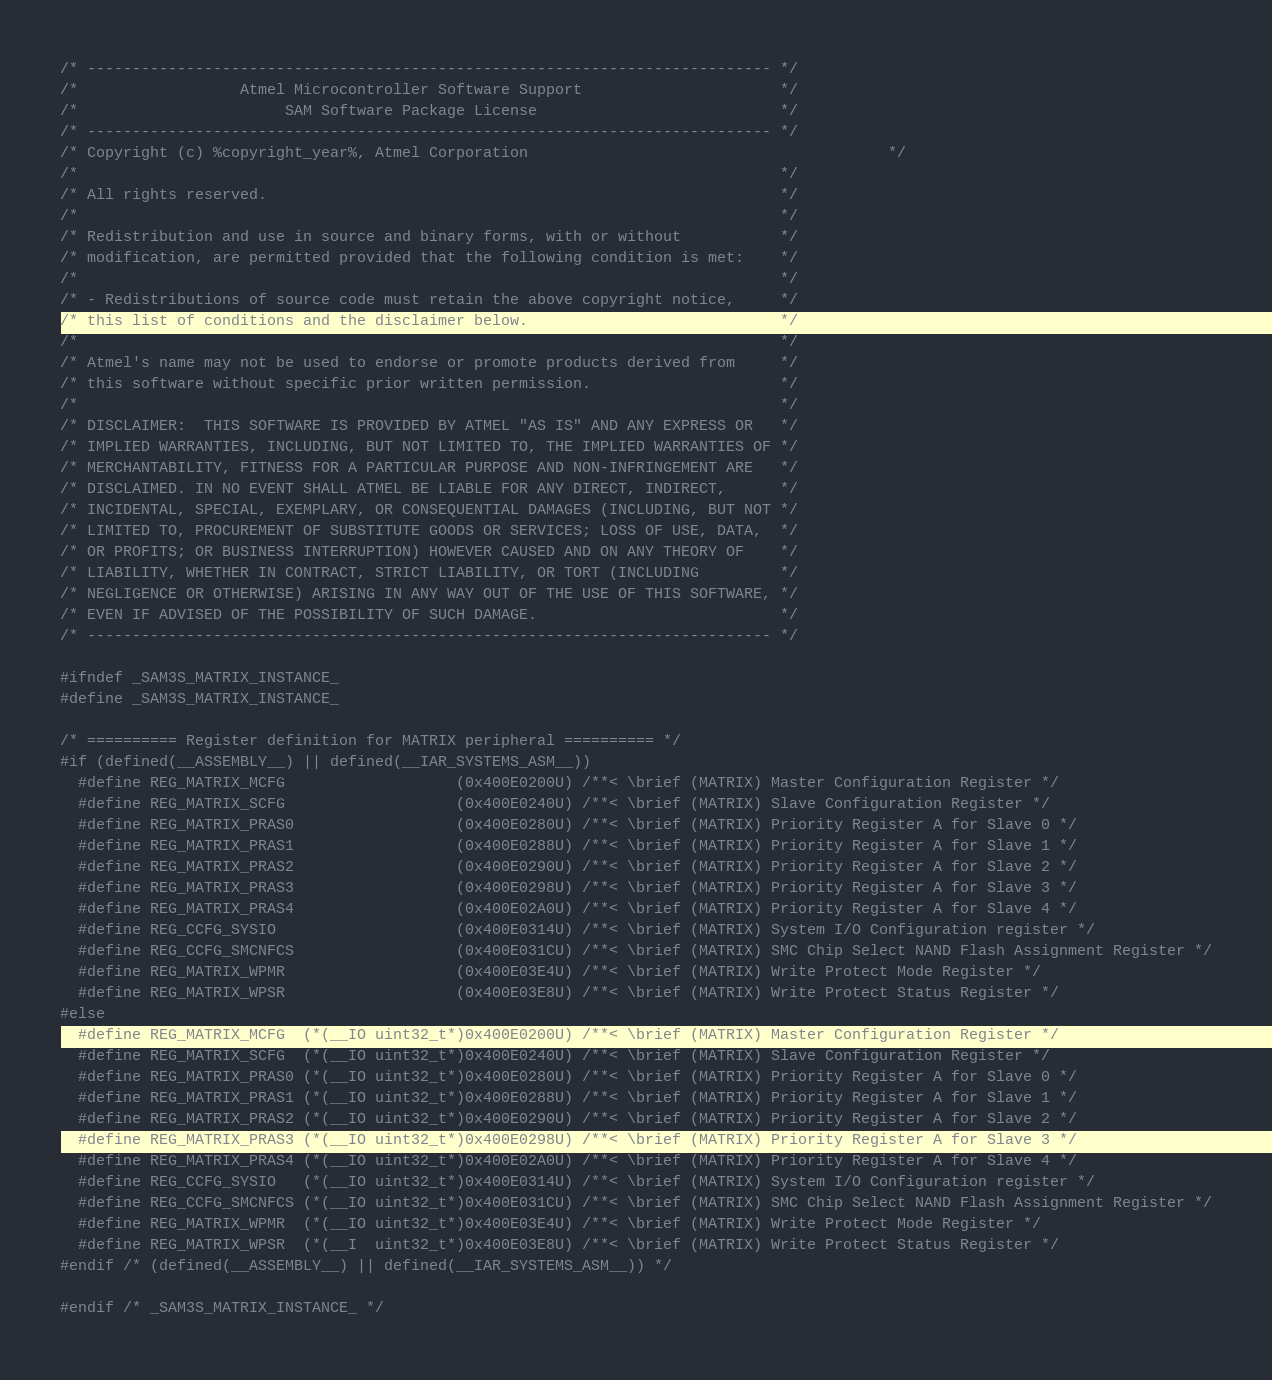<code> <loc_0><loc_0><loc_500><loc_500><_C_>/* ---------------------------------------------------------------------------- */
/*                  Atmel Microcontroller Software Support                      */
/*                       SAM Software Package License                           */
/* ---------------------------------------------------------------------------- */
/* Copyright (c) %copyright_year%, Atmel Corporation                                        */
/*                                                                              */
/* All rights reserved.                                                         */
/*                                                                              */
/* Redistribution and use in source and binary forms, with or without           */
/* modification, are permitted provided that the following condition is met:    */
/*                                                                              */
/* - Redistributions of source code must retain the above copyright notice,     */
/* this list of conditions and the disclaimer below.                            */
/*                                                                              */
/* Atmel's name may not be used to endorse or promote products derived from     */
/* this software without specific prior written permission.                     */
/*                                                                              */
/* DISCLAIMER:  THIS SOFTWARE IS PROVIDED BY ATMEL "AS IS" AND ANY EXPRESS OR   */
/* IMPLIED WARRANTIES, INCLUDING, BUT NOT LIMITED TO, THE IMPLIED WARRANTIES OF */
/* MERCHANTABILITY, FITNESS FOR A PARTICULAR PURPOSE AND NON-INFRINGEMENT ARE   */
/* DISCLAIMED. IN NO EVENT SHALL ATMEL BE LIABLE FOR ANY DIRECT, INDIRECT,      */
/* INCIDENTAL, SPECIAL, EXEMPLARY, OR CONSEQUENTIAL DAMAGES (INCLUDING, BUT NOT */
/* LIMITED TO, PROCUREMENT OF SUBSTITUTE GOODS OR SERVICES; LOSS OF USE, DATA,  */
/* OR PROFITS; OR BUSINESS INTERRUPTION) HOWEVER CAUSED AND ON ANY THEORY OF    */
/* LIABILITY, WHETHER IN CONTRACT, STRICT LIABILITY, OR TORT (INCLUDING         */
/* NEGLIGENCE OR OTHERWISE) ARISING IN ANY WAY OUT OF THE USE OF THIS SOFTWARE, */
/* EVEN IF ADVISED OF THE POSSIBILITY OF SUCH DAMAGE.                           */
/* ---------------------------------------------------------------------------- */

#ifndef _SAM3S_MATRIX_INSTANCE_
#define _SAM3S_MATRIX_INSTANCE_

/* ========== Register definition for MATRIX peripheral ========== */
#if (defined(__ASSEMBLY__) || defined(__IAR_SYSTEMS_ASM__))
  #define REG_MATRIX_MCFG                   (0x400E0200U) /**< \brief (MATRIX) Master Configuration Register */
  #define REG_MATRIX_SCFG                   (0x400E0240U) /**< \brief (MATRIX) Slave Configuration Register */
  #define REG_MATRIX_PRAS0                  (0x400E0280U) /**< \brief (MATRIX) Priority Register A for Slave 0 */
  #define REG_MATRIX_PRAS1                  (0x400E0288U) /**< \brief (MATRIX) Priority Register A for Slave 1 */
  #define REG_MATRIX_PRAS2                  (0x400E0290U) /**< \brief (MATRIX) Priority Register A for Slave 2 */
  #define REG_MATRIX_PRAS3                  (0x400E0298U) /**< \brief (MATRIX) Priority Register A for Slave 3 */
  #define REG_MATRIX_PRAS4                  (0x400E02A0U) /**< \brief (MATRIX) Priority Register A for Slave 4 */
  #define REG_CCFG_SYSIO                    (0x400E0314U) /**< \brief (MATRIX) System I/O Configuration register */
  #define REG_CCFG_SMCNFCS                  (0x400E031CU) /**< \brief (MATRIX) SMC Chip Select NAND Flash Assignment Register */
  #define REG_MATRIX_WPMR                   (0x400E03E4U) /**< \brief (MATRIX) Write Protect Mode Register */
  #define REG_MATRIX_WPSR                   (0x400E03E8U) /**< \brief (MATRIX) Write Protect Status Register */
#else
  #define REG_MATRIX_MCFG  (*(__IO uint32_t*)0x400E0200U) /**< \brief (MATRIX) Master Configuration Register */
  #define REG_MATRIX_SCFG  (*(__IO uint32_t*)0x400E0240U) /**< \brief (MATRIX) Slave Configuration Register */
  #define REG_MATRIX_PRAS0 (*(__IO uint32_t*)0x400E0280U) /**< \brief (MATRIX) Priority Register A for Slave 0 */
  #define REG_MATRIX_PRAS1 (*(__IO uint32_t*)0x400E0288U) /**< \brief (MATRIX) Priority Register A for Slave 1 */
  #define REG_MATRIX_PRAS2 (*(__IO uint32_t*)0x400E0290U) /**< \brief (MATRIX) Priority Register A for Slave 2 */
  #define REG_MATRIX_PRAS3 (*(__IO uint32_t*)0x400E0298U) /**< \brief (MATRIX) Priority Register A for Slave 3 */
  #define REG_MATRIX_PRAS4 (*(__IO uint32_t*)0x400E02A0U) /**< \brief (MATRIX) Priority Register A for Slave 4 */
  #define REG_CCFG_SYSIO   (*(__IO uint32_t*)0x400E0314U) /**< \brief (MATRIX) System I/O Configuration register */
  #define REG_CCFG_SMCNFCS (*(__IO uint32_t*)0x400E031CU) /**< \brief (MATRIX) SMC Chip Select NAND Flash Assignment Register */
  #define REG_MATRIX_WPMR  (*(__IO uint32_t*)0x400E03E4U) /**< \brief (MATRIX) Write Protect Mode Register */
  #define REG_MATRIX_WPSR  (*(__I  uint32_t*)0x400E03E8U) /**< \brief (MATRIX) Write Protect Status Register */
#endif /* (defined(__ASSEMBLY__) || defined(__IAR_SYSTEMS_ASM__)) */

#endif /* _SAM3S_MATRIX_INSTANCE_ */
</code> 